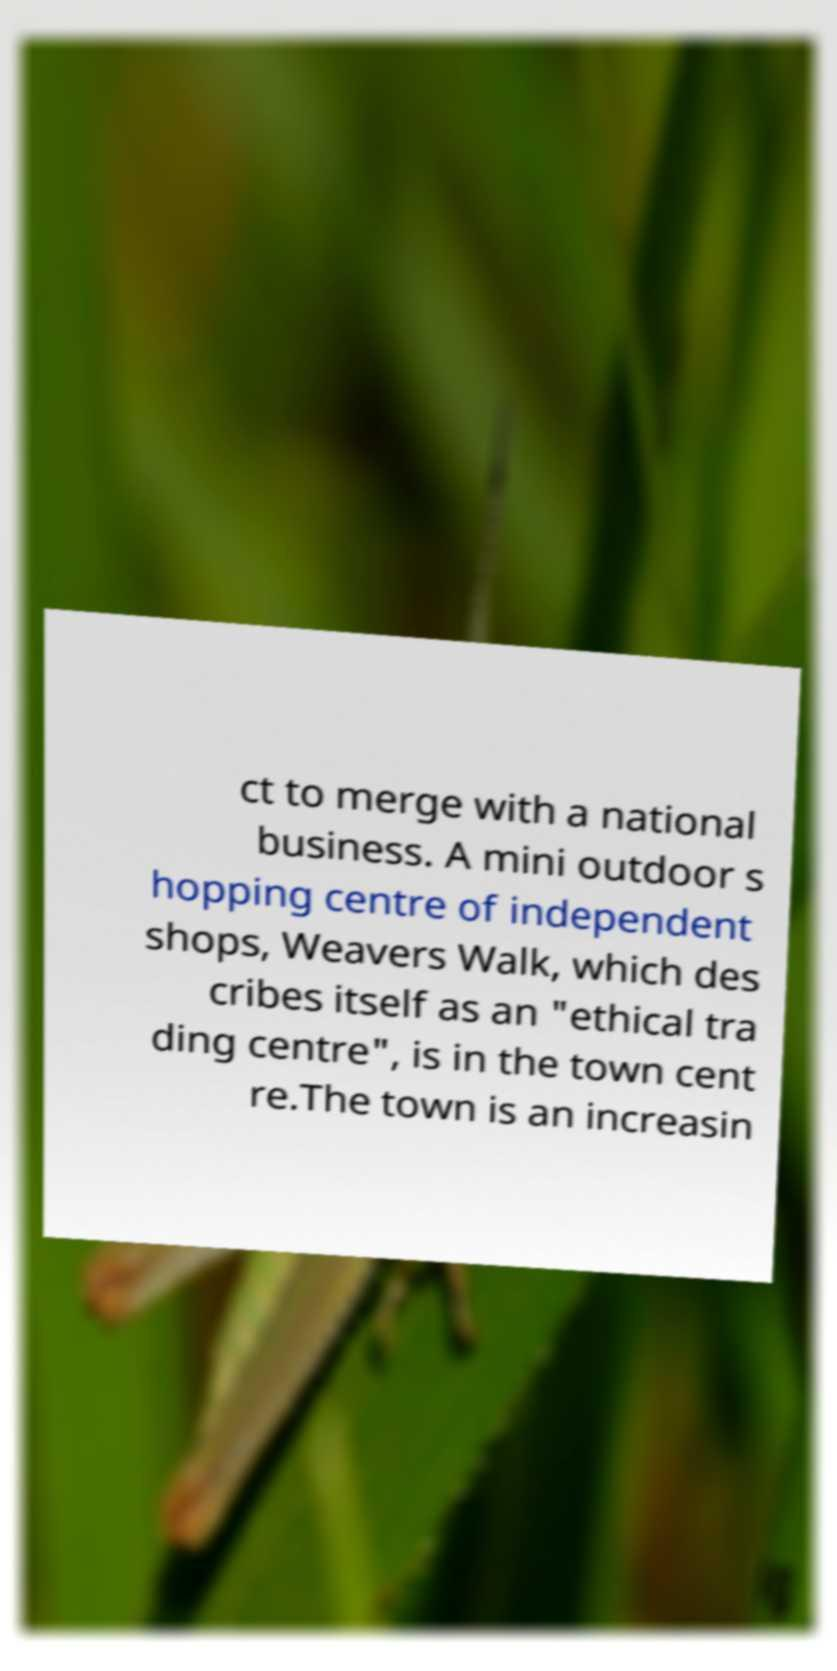Can you read and provide the text displayed in the image?This photo seems to have some interesting text. Can you extract and type it out for me? ct to merge with a national business. A mini outdoor s hopping centre of independent shops, Weavers Walk, which des cribes itself as an "ethical tra ding centre", is in the town cent re.The town is an increasin 